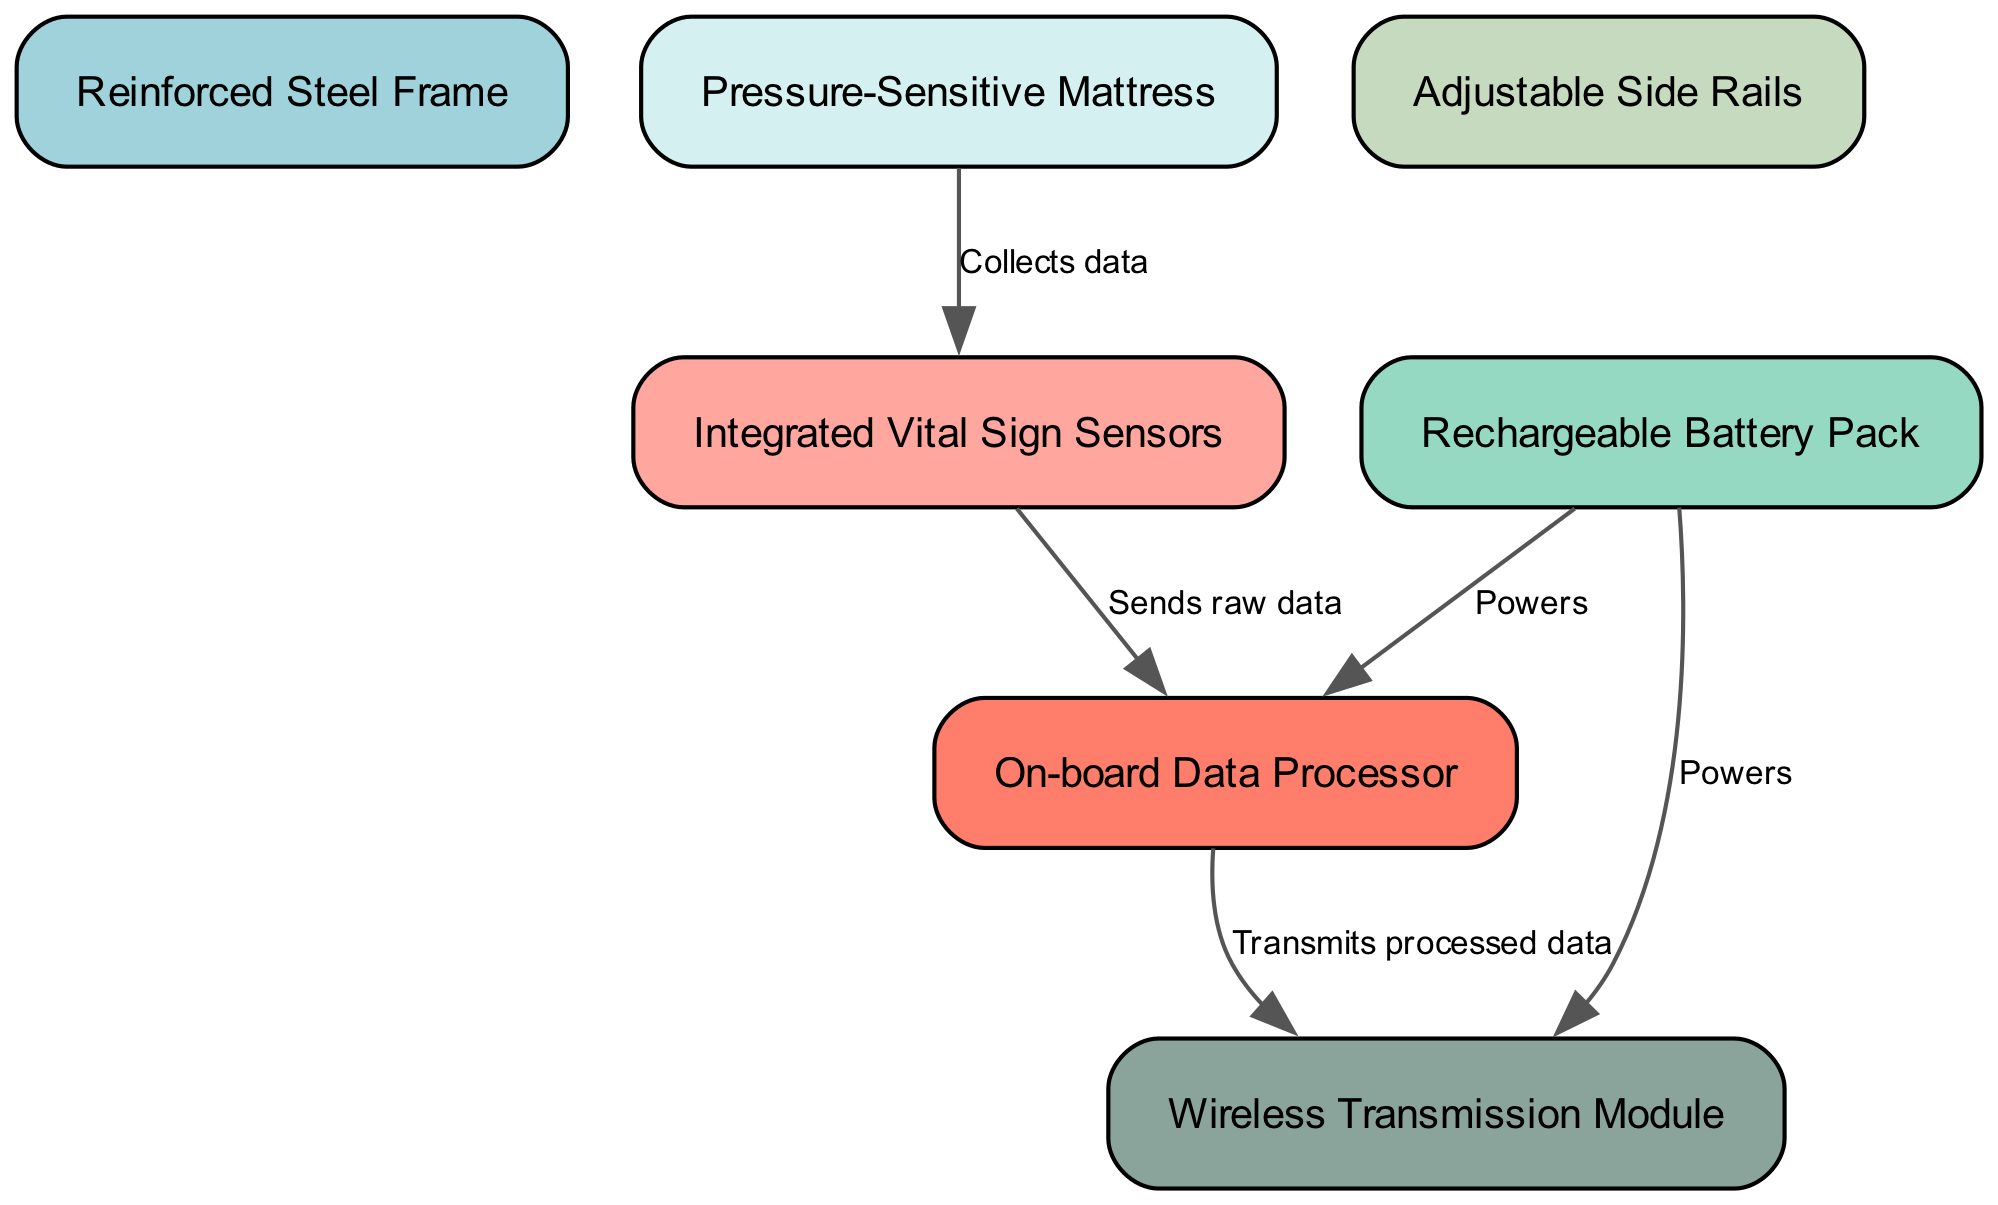What is the first component that collects data? The diagram shows that the "Pressure-Sensitive Mattress" is the first component listed that collects data from patients, which is indicated by the arrow pointing to "Integrated Vital Sign Sensors."
Answer: Pressure-Sensitive Mattress How many nodes are present in the diagram? By counting the nodes in the diagram, we can identify that there are seven distinct components denoted: "Reinforced Steel Frame," "Pressure-Sensitive Mattress," "Integrated Vital Sign Sensors," "On-board Data Processor," "Wireless Transmission Module," "Rechargeable Battery Pack," and "Adjustable Side Rails."
Answer: 7 Which two components are responsible for power supply? The diagram's edges indicate that both "Rechargeable Battery Pack" connects to "On-board Data Processor" and "Wireless Transmission Module," meaning these two components are powered by the battery.
Answer: Rechargeable Battery Pack, Wireless Transmission Module What does the "Integrated Vital Sign Sensors" send to the "On-board Data Processor"? The edge in the diagram specifies that the "Integrated Vital Sign Sensors" sends "raw data" to the "On-board Data Processor," indicating the flow of information between these two components.
Answer: Raw data Which component transmits processed data wirelessly? The arrow from "On-board Data Processor" to "Wireless Transmission Module" clearly indicates that the processed data is transmitted wirelessly by the "Wireless Transmission Module."
Answer: Wireless Transmission Module What is the role of the "Adjustable Side Rails"? The diagram includes the "Adjustable Side Rails" as one of the components, but there is no data connection indicating a specific function related to data flow or power, suggesting it serves a functional role within the bed structure rather than actively participating in data processing or transmission.
Answer: Structural role Which component does the "Rechargeable Battery Pack" power? The diagram shows two connections from the "Rechargeable Battery Pack," indicating it powers both the "On-board Data Processor" and the "Wireless Transmission Module." Therefore, it supplies energy to both of these components as indicated by the edges.
Answer: On-board Data Processor, Wireless Transmission Module 